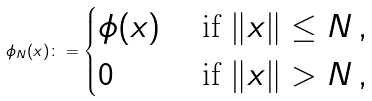Convert formula to latex. <formula><loc_0><loc_0><loc_500><loc_500>\phi _ { N } ( x ) \colon = \begin{cases} \phi ( x ) & \text { if } \| x \| \leq N \, , \\ 0 & \text { if } \| x \| > N \, , \end{cases}</formula> 